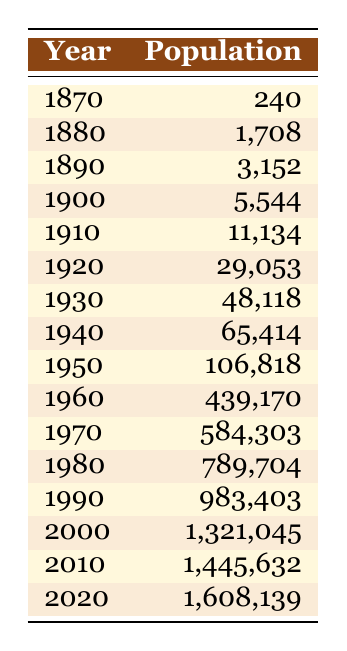What was the population of Phoenix in 1900? The table shows the year 1900, with the corresponding population listed as 5,544.
Answer: 5,544 What was the population growth from 1950 to 1960? The population in 1950 was 106,818 and in 1960 it was 439,170. To find the growth, subtract 1950's population from 1960's: 439,170 - 106,818 = 332,352.
Answer: 332,352 Is the population of Phoenix in 2020 greater than 1.5 million? The table states that the population in 2020 is 1,608,139, which is greater than 1.5 million.
Answer: Yes What was the average population of Phoenix from 1870 to 2020? To calculate the average, sum the population figures for all the years listed: (240 + 1,708 + 3,152 + 5,544 + 11,134 + 29,053 + 48,118 + 65,414 + 106,818 + 439,170 + 584,303 + 789,704 + 983,403 + 1,321,045 + 1,445,632 + 1,608,139) = 4,543,024. There are 15 years. Dividing gives: 4,543,024 / 15 = 302,868.27.
Answer: 302,868 What year had the largest population increase compared to the previous decade? To find this, compare the population of each decade with the previous decade: 1950 to 1960 (332,352), 1960 to 1970 (145,133), 1970 to 1980 (205,401), 1980 to 1990 (193,699), 1990 to 2000 (337,642), 2000 to 2010 (124,587), 2010 to 2020 (162,507). The largest increase was from 1950 to 1960 with 332,352.
Answer: 1950 to 1960 What was the population in the decade of the 1980s? The population in 1980 was 789,704 and in 1990 it was 983,403. The decade includes these two values.
Answer: 789,704 (in 1980) and 983,403 (in 1990) 